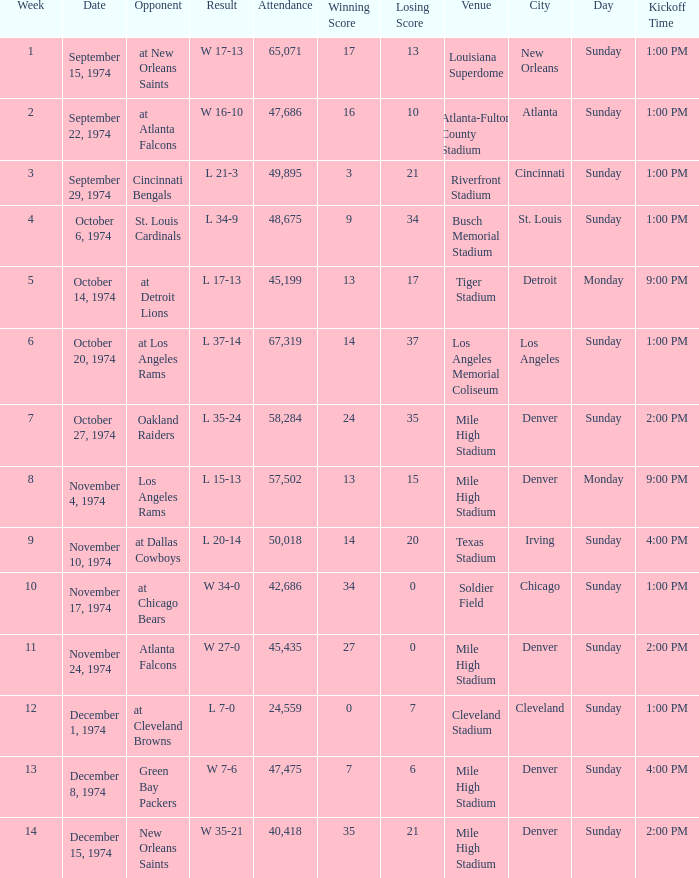What was the result before week 13 when they played the Oakland Raiders? L 35-24. 